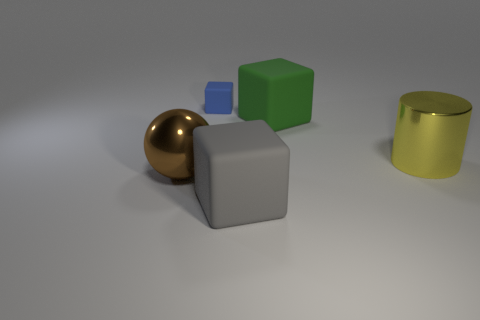What can we infer about the texture of the various objects? The textures vary significantly among the objects. The brown sphere and the gold cylinder exhibit smooth and reflective surfaces, indicating a polished or metallic texture. In contrast, the gray cube appears to have a rough, matte finish reminiscent of concrete or stone. The green cube has a slightly reflective surface suggesting a plastic or painted wood texture, while the translucent blue cube gives the impression of glass or acrylic material with its semi-transparent appearance. Are there any indications about the scale or size of these objects? Without a clear reference object for scale, it's difficult to determine the exact size of these objects. However, they are presented in a way that leads us to assume they are relatively small, perhaps the size of typical objects one might find on a desk, like paperweights or decorative items. 